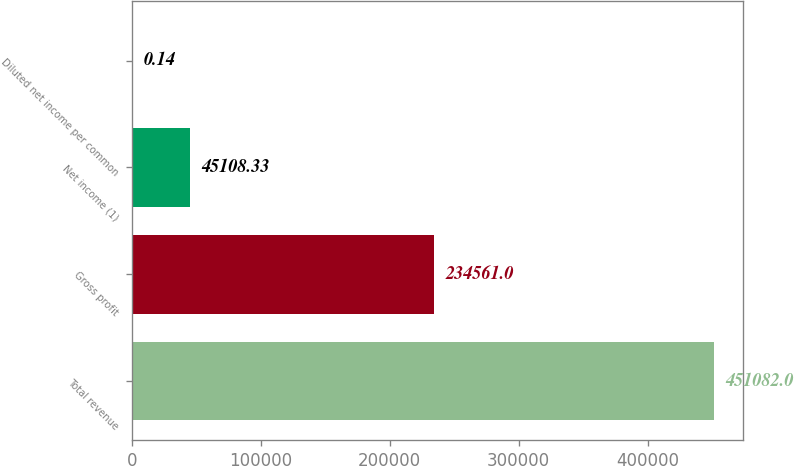Convert chart. <chart><loc_0><loc_0><loc_500><loc_500><bar_chart><fcel>Total revenue<fcel>Gross profit<fcel>Net income (1)<fcel>Diluted net income per common<nl><fcel>451082<fcel>234561<fcel>45108.3<fcel>0.14<nl></chart> 